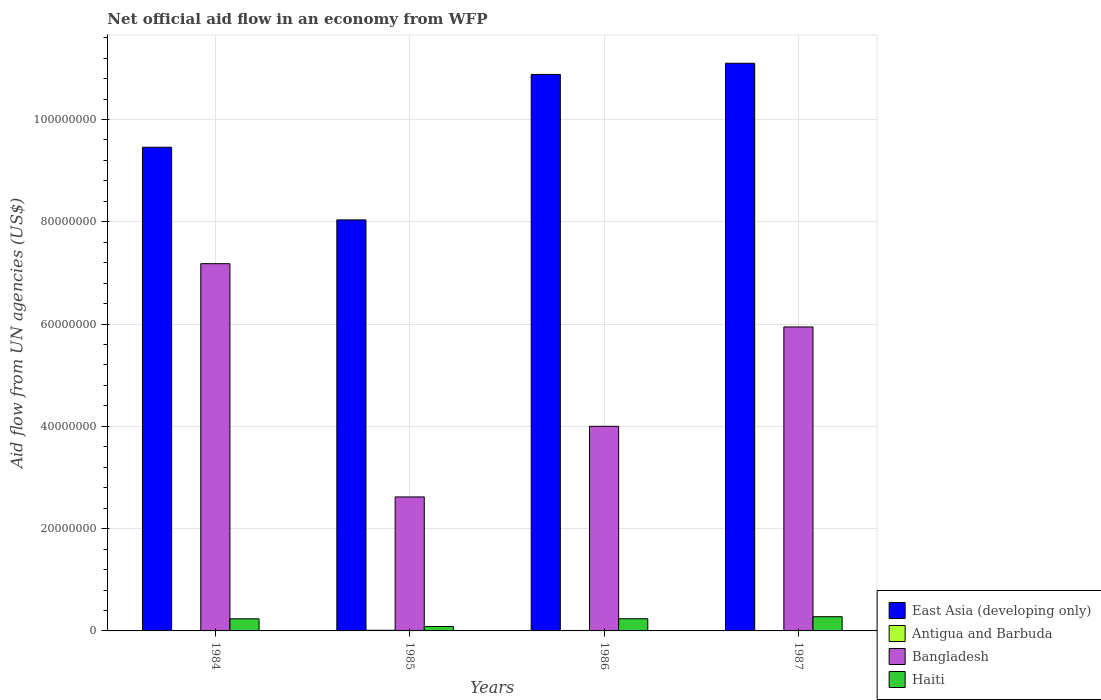How many different coloured bars are there?
Make the answer very short. 4. Are the number of bars on each tick of the X-axis equal?
Offer a terse response. Yes. What is the label of the 3rd group of bars from the left?
Offer a terse response. 1986. In how many cases, is the number of bars for a given year not equal to the number of legend labels?
Ensure brevity in your answer.  0. What is the net official aid flow in Bangladesh in 1987?
Ensure brevity in your answer.  5.94e+07. Across all years, what is the maximum net official aid flow in Haiti?
Give a very brief answer. 2.78e+06. Across all years, what is the minimum net official aid flow in East Asia (developing only)?
Ensure brevity in your answer.  8.04e+07. In which year was the net official aid flow in Bangladesh maximum?
Ensure brevity in your answer.  1984. What is the total net official aid flow in Haiti in the graph?
Make the answer very short. 8.39e+06. What is the difference between the net official aid flow in East Asia (developing only) in 1987 and the net official aid flow in Bangladesh in 1985?
Provide a short and direct response. 8.48e+07. What is the average net official aid flow in Antigua and Barbuda per year?
Provide a short and direct response. 8.25e+04. In the year 1984, what is the difference between the net official aid flow in East Asia (developing only) and net official aid flow in Bangladesh?
Keep it short and to the point. 2.28e+07. What is the ratio of the net official aid flow in Antigua and Barbuda in 1984 to that in 1985?
Your response must be concise. 0.31. Is the net official aid flow in Bangladesh in 1984 less than that in 1987?
Offer a very short reply. No. What is the difference between the highest and the second highest net official aid flow in Bangladesh?
Provide a short and direct response. 1.24e+07. In how many years, is the net official aid flow in East Asia (developing only) greater than the average net official aid flow in East Asia (developing only) taken over all years?
Make the answer very short. 2. What does the 1st bar from the left in 1985 represents?
Make the answer very short. East Asia (developing only). What does the 4th bar from the right in 1985 represents?
Provide a succinct answer. East Asia (developing only). How many bars are there?
Ensure brevity in your answer.  16. How many years are there in the graph?
Your answer should be very brief. 4. What is the difference between two consecutive major ticks on the Y-axis?
Provide a succinct answer. 2.00e+07. Does the graph contain any zero values?
Keep it short and to the point. No. Does the graph contain grids?
Your answer should be very brief. Yes. Where does the legend appear in the graph?
Your answer should be compact. Bottom right. How many legend labels are there?
Provide a short and direct response. 4. What is the title of the graph?
Your answer should be very brief. Net official aid flow in an economy from WFP. Does "French Polynesia" appear as one of the legend labels in the graph?
Provide a short and direct response. No. What is the label or title of the X-axis?
Offer a very short reply. Years. What is the label or title of the Y-axis?
Offer a terse response. Aid flow from UN agencies (US$). What is the Aid flow from UN agencies (US$) of East Asia (developing only) in 1984?
Provide a succinct answer. 9.46e+07. What is the Aid flow from UN agencies (US$) in Antigua and Barbuda in 1984?
Your answer should be compact. 4.00e+04. What is the Aid flow from UN agencies (US$) of Bangladesh in 1984?
Offer a terse response. 7.18e+07. What is the Aid flow from UN agencies (US$) in Haiti in 1984?
Your response must be concise. 2.37e+06. What is the Aid flow from UN agencies (US$) in East Asia (developing only) in 1985?
Offer a terse response. 8.04e+07. What is the Aid flow from UN agencies (US$) in Antigua and Barbuda in 1985?
Your answer should be very brief. 1.30e+05. What is the Aid flow from UN agencies (US$) of Bangladesh in 1985?
Give a very brief answer. 2.62e+07. What is the Aid flow from UN agencies (US$) in Haiti in 1985?
Provide a succinct answer. 8.60e+05. What is the Aid flow from UN agencies (US$) of East Asia (developing only) in 1986?
Keep it short and to the point. 1.09e+08. What is the Aid flow from UN agencies (US$) of Antigua and Barbuda in 1986?
Give a very brief answer. 9.00e+04. What is the Aid flow from UN agencies (US$) of Bangladesh in 1986?
Your answer should be compact. 4.00e+07. What is the Aid flow from UN agencies (US$) in Haiti in 1986?
Your answer should be compact. 2.38e+06. What is the Aid flow from UN agencies (US$) in East Asia (developing only) in 1987?
Your response must be concise. 1.11e+08. What is the Aid flow from UN agencies (US$) in Antigua and Barbuda in 1987?
Your answer should be compact. 7.00e+04. What is the Aid flow from UN agencies (US$) of Bangladesh in 1987?
Make the answer very short. 5.94e+07. What is the Aid flow from UN agencies (US$) of Haiti in 1987?
Your answer should be compact. 2.78e+06. Across all years, what is the maximum Aid flow from UN agencies (US$) of East Asia (developing only)?
Make the answer very short. 1.11e+08. Across all years, what is the maximum Aid flow from UN agencies (US$) of Antigua and Barbuda?
Give a very brief answer. 1.30e+05. Across all years, what is the maximum Aid flow from UN agencies (US$) in Bangladesh?
Offer a very short reply. 7.18e+07. Across all years, what is the maximum Aid flow from UN agencies (US$) of Haiti?
Provide a succinct answer. 2.78e+06. Across all years, what is the minimum Aid flow from UN agencies (US$) of East Asia (developing only)?
Give a very brief answer. 8.04e+07. Across all years, what is the minimum Aid flow from UN agencies (US$) of Antigua and Barbuda?
Keep it short and to the point. 4.00e+04. Across all years, what is the minimum Aid flow from UN agencies (US$) in Bangladesh?
Offer a terse response. 2.62e+07. Across all years, what is the minimum Aid flow from UN agencies (US$) of Haiti?
Provide a short and direct response. 8.60e+05. What is the total Aid flow from UN agencies (US$) of East Asia (developing only) in the graph?
Offer a terse response. 3.95e+08. What is the total Aid flow from UN agencies (US$) of Antigua and Barbuda in the graph?
Provide a short and direct response. 3.30e+05. What is the total Aid flow from UN agencies (US$) in Bangladesh in the graph?
Offer a very short reply. 1.97e+08. What is the total Aid flow from UN agencies (US$) of Haiti in the graph?
Ensure brevity in your answer.  8.39e+06. What is the difference between the Aid flow from UN agencies (US$) in East Asia (developing only) in 1984 and that in 1985?
Make the answer very short. 1.42e+07. What is the difference between the Aid flow from UN agencies (US$) of Antigua and Barbuda in 1984 and that in 1985?
Provide a short and direct response. -9.00e+04. What is the difference between the Aid flow from UN agencies (US$) of Bangladesh in 1984 and that in 1985?
Offer a terse response. 4.56e+07. What is the difference between the Aid flow from UN agencies (US$) of Haiti in 1984 and that in 1985?
Provide a succinct answer. 1.51e+06. What is the difference between the Aid flow from UN agencies (US$) of East Asia (developing only) in 1984 and that in 1986?
Give a very brief answer. -1.42e+07. What is the difference between the Aid flow from UN agencies (US$) in Antigua and Barbuda in 1984 and that in 1986?
Make the answer very short. -5.00e+04. What is the difference between the Aid flow from UN agencies (US$) of Bangladesh in 1984 and that in 1986?
Offer a terse response. 3.18e+07. What is the difference between the Aid flow from UN agencies (US$) of Haiti in 1984 and that in 1986?
Your response must be concise. -10000. What is the difference between the Aid flow from UN agencies (US$) in East Asia (developing only) in 1984 and that in 1987?
Ensure brevity in your answer.  -1.64e+07. What is the difference between the Aid flow from UN agencies (US$) in Antigua and Barbuda in 1984 and that in 1987?
Make the answer very short. -3.00e+04. What is the difference between the Aid flow from UN agencies (US$) of Bangladesh in 1984 and that in 1987?
Provide a succinct answer. 1.24e+07. What is the difference between the Aid flow from UN agencies (US$) in Haiti in 1984 and that in 1987?
Your answer should be very brief. -4.10e+05. What is the difference between the Aid flow from UN agencies (US$) in East Asia (developing only) in 1985 and that in 1986?
Provide a succinct answer. -2.84e+07. What is the difference between the Aid flow from UN agencies (US$) in Bangladesh in 1985 and that in 1986?
Ensure brevity in your answer.  -1.38e+07. What is the difference between the Aid flow from UN agencies (US$) in Haiti in 1985 and that in 1986?
Provide a short and direct response. -1.52e+06. What is the difference between the Aid flow from UN agencies (US$) of East Asia (developing only) in 1985 and that in 1987?
Offer a terse response. -3.06e+07. What is the difference between the Aid flow from UN agencies (US$) of Bangladesh in 1985 and that in 1987?
Make the answer very short. -3.32e+07. What is the difference between the Aid flow from UN agencies (US$) in Haiti in 1985 and that in 1987?
Your response must be concise. -1.92e+06. What is the difference between the Aid flow from UN agencies (US$) of East Asia (developing only) in 1986 and that in 1987?
Offer a very short reply. -2.19e+06. What is the difference between the Aid flow from UN agencies (US$) of Bangladesh in 1986 and that in 1987?
Make the answer very short. -1.94e+07. What is the difference between the Aid flow from UN agencies (US$) in Haiti in 1986 and that in 1987?
Provide a short and direct response. -4.00e+05. What is the difference between the Aid flow from UN agencies (US$) of East Asia (developing only) in 1984 and the Aid flow from UN agencies (US$) of Antigua and Barbuda in 1985?
Give a very brief answer. 9.44e+07. What is the difference between the Aid flow from UN agencies (US$) in East Asia (developing only) in 1984 and the Aid flow from UN agencies (US$) in Bangladesh in 1985?
Your answer should be very brief. 6.84e+07. What is the difference between the Aid flow from UN agencies (US$) in East Asia (developing only) in 1984 and the Aid flow from UN agencies (US$) in Haiti in 1985?
Provide a succinct answer. 9.37e+07. What is the difference between the Aid flow from UN agencies (US$) in Antigua and Barbuda in 1984 and the Aid flow from UN agencies (US$) in Bangladesh in 1985?
Provide a short and direct response. -2.62e+07. What is the difference between the Aid flow from UN agencies (US$) in Antigua and Barbuda in 1984 and the Aid flow from UN agencies (US$) in Haiti in 1985?
Your answer should be very brief. -8.20e+05. What is the difference between the Aid flow from UN agencies (US$) in Bangladesh in 1984 and the Aid flow from UN agencies (US$) in Haiti in 1985?
Make the answer very short. 7.10e+07. What is the difference between the Aid flow from UN agencies (US$) of East Asia (developing only) in 1984 and the Aid flow from UN agencies (US$) of Antigua and Barbuda in 1986?
Your response must be concise. 9.45e+07. What is the difference between the Aid flow from UN agencies (US$) of East Asia (developing only) in 1984 and the Aid flow from UN agencies (US$) of Bangladesh in 1986?
Your answer should be very brief. 5.46e+07. What is the difference between the Aid flow from UN agencies (US$) in East Asia (developing only) in 1984 and the Aid flow from UN agencies (US$) in Haiti in 1986?
Keep it short and to the point. 9.22e+07. What is the difference between the Aid flow from UN agencies (US$) in Antigua and Barbuda in 1984 and the Aid flow from UN agencies (US$) in Bangladesh in 1986?
Your response must be concise. -4.00e+07. What is the difference between the Aid flow from UN agencies (US$) in Antigua and Barbuda in 1984 and the Aid flow from UN agencies (US$) in Haiti in 1986?
Provide a succinct answer. -2.34e+06. What is the difference between the Aid flow from UN agencies (US$) of Bangladesh in 1984 and the Aid flow from UN agencies (US$) of Haiti in 1986?
Your answer should be compact. 6.94e+07. What is the difference between the Aid flow from UN agencies (US$) of East Asia (developing only) in 1984 and the Aid flow from UN agencies (US$) of Antigua and Barbuda in 1987?
Make the answer very short. 9.45e+07. What is the difference between the Aid flow from UN agencies (US$) in East Asia (developing only) in 1984 and the Aid flow from UN agencies (US$) in Bangladesh in 1987?
Offer a very short reply. 3.51e+07. What is the difference between the Aid flow from UN agencies (US$) in East Asia (developing only) in 1984 and the Aid flow from UN agencies (US$) in Haiti in 1987?
Your answer should be compact. 9.18e+07. What is the difference between the Aid flow from UN agencies (US$) in Antigua and Barbuda in 1984 and the Aid flow from UN agencies (US$) in Bangladesh in 1987?
Offer a terse response. -5.94e+07. What is the difference between the Aid flow from UN agencies (US$) in Antigua and Barbuda in 1984 and the Aid flow from UN agencies (US$) in Haiti in 1987?
Make the answer very short. -2.74e+06. What is the difference between the Aid flow from UN agencies (US$) of Bangladesh in 1984 and the Aid flow from UN agencies (US$) of Haiti in 1987?
Ensure brevity in your answer.  6.90e+07. What is the difference between the Aid flow from UN agencies (US$) in East Asia (developing only) in 1985 and the Aid flow from UN agencies (US$) in Antigua and Barbuda in 1986?
Provide a short and direct response. 8.03e+07. What is the difference between the Aid flow from UN agencies (US$) of East Asia (developing only) in 1985 and the Aid flow from UN agencies (US$) of Bangladesh in 1986?
Your answer should be compact. 4.04e+07. What is the difference between the Aid flow from UN agencies (US$) in East Asia (developing only) in 1985 and the Aid flow from UN agencies (US$) in Haiti in 1986?
Provide a short and direct response. 7.80e+07. What is the difference between the Aid flow from UN agencies (US$) of Antigua and Barbuda in 1985 and the Aid flow from UN agencies (US$) of Bangladesh in 1986?
Provide a succinct answer. -3.99e+07. What is the difference between the Aid flow from UN agencies (US$) in Antigua and Barbuda in 1985 and the Aid flow from UN agencies (US$) in Haiti in 1986?
Your answer should be compact. -2.25e+06. What is the difference between the Aid flow from UN agencies (US$) in Bangladesh in 1985 and the Aid flow from UN agencies (US$) in Haiti in 1986?
Ensure brevity in your answer.  2.38e+07. What is the difference between the Aid flow from UN agencies (US$) of East Asia (developing only) in 1985 and the Aid flow from UN agencies (US$) of Antigua and Barbuda in 1987?
Offer a very short reply. 8.03e+07. What is the difference between the Aid flow from UN agencies (US$) in East Asia (developing only) in 1985 and the Aid flow from UN agencies (US$) in Bangladesh in 1987?
Offer a terse response. 2.09e+07. What is the difference between the Aid flow from UN agencies (US$) of East Asia (developing only) in 1985 and the Aid flow from UN agencies (US$) of Haiti in 1987?
Make the answer very short. 7.76e+07. What is the difference between the Aid flow from UN agencies (US$) of Antigua and Barbuda in 1985 and the Aid flow from UN agencies (US$) of Bangladesh in 1987?
Make the answer very short. -5.93e+07. What is the difference between the Aid flow from UN agencies (US$) of Antigua and Barbuda in 1985 and the Aid flow from UN agencies (US$) of Haiti in 1987?
Your answer should be very brief. -2.65e+06. What is the difference between the Aid flow from UN agencies (US$) in Bangladesh in 1985 and the Aid flow from UN agencies (US$) in Haiti in 1987?
Make the answer very short. 2.34e+07. What is the difference between the Aid flow from UN agencies (US$) of East Asia (developing only) in 1986 and the Aid flow from UN agencies (US$) of Antigua and Barbuda in 1987?
Provide a short and direct response. 1.09e+08. What is the difference between the Aid flow from UN agencies (US$) of East Asia (developing only) in 1986 and the Aid flow from UN agencies (US$) of Bangladesh in 1987?
Keep it short and to the point. 4.94e+07. What is the difference between the Aid flow from UN agencies (US$) in East Asia (developing only) in 1986 and the Aid flow from UN agencies (US$) in Haiti in 1987?
Offer a very short reply. 1.06e+08. What is the difference between the Aid flow from UN agencies (US$) of Antigua and Barbuda in 1986 and the Aid flow from UN agencies (US$) of Bangladesh in 1987?
Ensure brevity in your answer.  -5.94e+07. What is the difference between the Aid flow from UN agencies (US$) of Antigua and Barbuda in 1986 and the Aid flow from UN agencies (US$) of Haiti in 1987?
Your response must be concise. -2.69e+06. What is the difference between the Aid flow from UN agencies (US$) in Bangladesh in 1986 and the Aid flow from UN agencies (US$) in Haiti in 1987?
Keep it short and to the point. 3.72e+07. What is the average Aid flow from UN agencies (US$) in East Asia (developing only) per year?
Your answer should be very brief. 9.87e+07. What is the average Aid flow from UN agencies (US$) in Antigua and Barbuda per year?
Make the answer very short. 8.25e+04. What is the average Aid flow from UN agencies (US$) of Bangladesh per year?
Make the answer very short. 4.94e+07. What is the average Aid flow from UN agencies (US$) in Haiti per year?
Give a very brief answer. 2.10e+06. In the year 1984, what is the difference between the Aid flow from UN agencies (US$) of East Asia (developing only) and Aid flow from UN agencies (US$) of Antigua and Barbuda?
Provide a succinct answer. 9.45e+07. In the year 1984, what is the difference between the Aid flow from UN agencies (US$) in East Asia (developing only) and Aid flow from UN agencies (US$) in Bangladesh?
Keep it short and to the point. 2.28e+07. In the year 1984, what is the difference between the Aid flow from UN agencies (US$) in East Asia (developing only) and Aid flow from UN agencies (US$) in Haiti?
Offer a terse response. 9.22e+07. In the year 1984, what is the difference between the Aid flow from UN agencies (US$) of Antigua and Barbuda and Aid flow from UN agencies (US$) of Bangladesh?
Make the answer very short. -7.18e+07. In the year 1984, what is the difference between the Aid flow from UN agencies (US$) in Antigua and Barbuda and Aid flow from UN agencies (US$) in Haiti?
Offer a terse response. -2.33e+06. In the year 1984, what is the difference between the Aid flow from UN agencies (US$) in Bangladesh and Aid flow from UN agencies (US$) in Haiti?
Your answer should be compact. 6.94e+07. In the year 1985, what is the difference between the Aid flow from UN agencies (US$) in East Asia (developing only) and Aid flow from UN agencies (US$) in Antigua and Barbuda?
Provide a short and direct response. 8.02e+07. In the year 1985, what is the difference between the Aid flow from UN agencies (US$) in East Asia (developing only) and Aid flow from UN agencies (US$) in Bangladesh?
Offer a very short reply. 5.42e+07. In the year 1985, what is the difference between the Aid flow from UN agencies (US$) in East Asia (developing only) and Aid flow from UN agencies (US$) in Haiti?
Provide a short and direct response. 7.95e+07. In the year 1985, what is the difference between the Aid flow from UN agencies (US$) of Antigua and Barbuda and Aid flow from UN agencies (US$) of Bangladesh?
Your answer should be very brief. -2.61e+07. In the year 1985, what is the difference between the Aid flow from UN agencies (US$) in Antigua and Barbuda and Aid flow from UN agencies (US$) in Haiti?
Offer a terse response. -7.30e+05. In the year 1985, what is the difference between the Aid flow from UN agencies (US$) of Bangladesh and Aid flow from UN agencies (US$) of Haiti?
Ensure brevity in your answer.  2.53e+07. In the year 1986, what is the difference between the Aid flow from UN agencies (US$) in East Asia (developing only) and Aid flow from UN agencies (US$) in Antigua and Barbuda?
Your answer should be very brief. 1.09e+08. In the year 1986, what is the difference between the Aid flow from UN agencies (US$) of East Asia (developing only) and Aid flow from UN agencies (US$) of Bangladesh?
Your answer should be compact. 6.88e+07. In the year 1986, what is the difference between the Aid flow from UN agencies (US$) of East Asia (developing only) and Aid flow from UN agencies (US$) of Haiti?
Your answer should be very brief. 1.06e+08. In the year 1986, what is the difference between the Aid flow from UN agencies (US$) in Antigua and Barbuda and Aid flow from UN agencies (US$) in Bangladesh?
Your answer should be very brief. -3.99e+07. In the year 1986, what is the difference between the Aid flow from UN agencies (US$) of Antigua and Barbuda and Aid flow from UN agencies (US$) of Haiti?
Offer a terse response. -2.29e+06. In the year 1986, what is the difference between the Aid flow from UN agencies (US$) of Bangladesh and Aid flow from UN agencies (US$) of Haiti?
Your answer should be very brief. 3.76e+07. In the year 1987, what is the difference between the Aid flow from UN agencies (US$) of East Asia (developing only) and Aid flow from UN agencies (US$) of Antigua and Barbuda?
Your answer should be compact. 1.11e+08. In the year 1987, what is the difference between the Aid flow from UN agencies (US$) of East Asia (developing only) and Aid flow from UN agencies (US$) of Bangladesh?
Your answer should be compact. 5.16e+07. In the year 1987, what is the difference between the Aid flow from UN agencies (US$) of East Asia (developing only) and Aid flow from UN agencies (US$) of Haiti?
Your answer should be very brief. 1.08e+08. In the year 1987, what is the difference between the Aid flow from UN agencies (US$) in Antigua and Barbuda and Aid flow from UN agencies (US$) in Bangladesh?
Offer a terse response. -5.94e+07. In the year 1987, what is the difference between the Aid flow from UN agencies (US$) of Antigua and Barbuda and Aid flow from UN agencies (US$) of Haiti?
Keep it short and to the point. -2.71e+06. In the year 1987, what is the difference between the Aid flow from UN agencies (US$) of Bangladesh and Aid flow from UN agencies (US$) of Haiti?
Provide a succinct answer. 5.67e+07. What is the ratio of the Aid flow from UN agencies (US$) in East Asia (developing only) in 1984 to that in 1985?
Ensure brevity in your answer.  1.18. What is the ratio of the Aid flow from UN agencies (US$) in Antigua and Barbuda in 1984 to that in 1985?
Your answer should be very brief. 0.31. What is the ratio of the Aid flow from UN agencies (US$) of Bangladesh in 1984 to that in 1985?
Keep it short and to the point. 2.74. What is the ratio of the Aid flow from UN agencies (US$) of Haiti in 1984 to that in 1985?
Give a very brief answer. 2.76. What is the ratio of the Aid flow from UN agencies (US$) in East Asia (developing only) in 1984 to that in 1986?
Your answer should be very brief. 0.87. What is the ratio of the Aid flow from UN agencies (US$) in Antigua and Barbuda in 1984 to that in 1986?
Make the answer very short. 0.44. What is the ratio of the Aid flow from UN agencies (US$) in Bangladesh in 1984 to that in 1986?
Your response must be concise. 1.79. What is the ratio of the Aid flow from UN agencies (US$) in Haiti in 1984 to that in 1986?
Your answer should be very brief. 1. What is the ratio of the Aid flow from UN agencies (US$) in East Asia (developing only) in 1984 to that in 1987?
Ensure brevity in your answer.  0.85. What is the ratio of the Aid flow from UN agencies (US$) of Bangladesh in 1984 to that in 1987?
Give a very brief answer. 1.21. What is the ratio of the Aid flow from UN agencies (US$) in Haiti in 1984 to that in 1987?
Ensure brevity in your answer.  0.85. What is the ratio of the Aid flow from UN agencies (US$) of East Asia (developing only) in 1985 to that in 1986?
Offer a very short reply. 0.74. What is the ratio of the Aid flow from UN agencies (US$) in Antigua and Barbuda in 1985 to that in 1986?
Ensure brevity in your answer.  1.44. What is the ratio of the Aid flow from UN agencies (US$) of Bangladesh in 1985 to that in 1986?
Provide a succinct answer. 0.65. What is the ratio of the Aid flow from UN agencies (US$) of Haiti in 1985 to that in 1986?
Give a very brief answer. 0.36. What is the ratio of the Aid flow from UN agencies (US$) of East Asia (developing only) in 1985 to that in 1987?
Your response must be concise. 0.72. What is the ratio of the Aid flow from UN agencies (US$) of Antigua and Barbuda in 1985 to that in 1987?
Your answer should be very brief. 1.86. What is the ratio of the Aid flow from UN agencies (US$) in Bangladesh in 1985 to that in 1987?
Your answer should be very brief. 0.44. What is the ratio of the Aid flow from UN agencies (US$) in Haiti in 1985 to that in 1987?
Offer a terse response. 0.31. What is the ratio of the Aid flow from UN agencies (US$) of East Asia (developing only) in 1986 to that in 1987?
Make the answer very short. 0.98. What is the ratio of the Aid flow from UN agencies (US$) in Bangladesh in 1986 to that in 1987?
Provide a succinct answer. 0.67. What is the ratio of the Aid flow from UN agencies (US$) in Haiti in 1986 to that in 1987?
Offer a very short reply. 0.86. What is the difference between the highest and the second highest Aid flow from UN agencies (US$) of East Asia (developing only)?
Ensure brevity in your answer.  2.19e+06. What is the difference between the highest and the second highest Aid flow from UN agencies (US$) of Antigua and Barbuda?
Ensure brevity in your answer.  4.00e+04. What is the difference between the highest and the second highest Aid flow from UN agencies (US$) in Bangladesh?
Keep it short and to the point. 1.24e+07. What is the difference between the highest and the lowest Aid flow from UN agencies (US$) of East Asia (developing only)?
Your answer should be very brief. 3.06e+07. What is the difference between the highest and the lowest Aid flow from UN agencies (US$) in Bangladesh?
Give a very brief answer. 4.56e+07. What is the difference between the highest and the lowest Aid flow from UN agencies (US$) in Haiti?
Keep it short and to the point. 1.92e+06. 